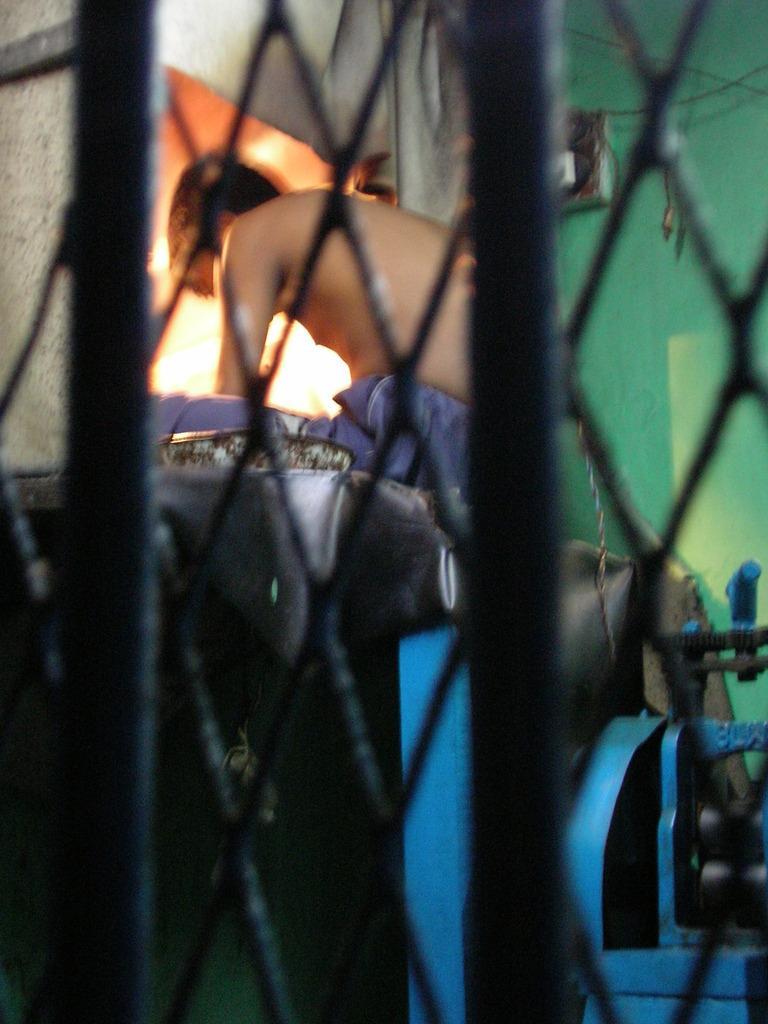Can you describe this image briefly? In this picture we can see a person sitting, rods, machine, box and some objects and in the background we can see the wall. 